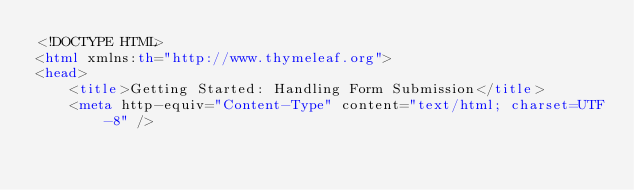Convert code to text. <code><loc_0><loc_0><loc_500><loc_500><_HTML_><!DOCTYPE HTML>
<html xmlns:th="http://www.thymeleaf.org">
<head>
    <title>Getting Started: Handling Form Submission</title>
    <meta http-equiv="Content-Type" content="text/html; charset=UTF-8" /></code> 